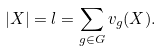Convert formula to latex. <formula><loc_0><loc_0><loc_500><loc_500>| X | = l = \sum _ { g \in G } v _ { g } ( X ) .</formula> 